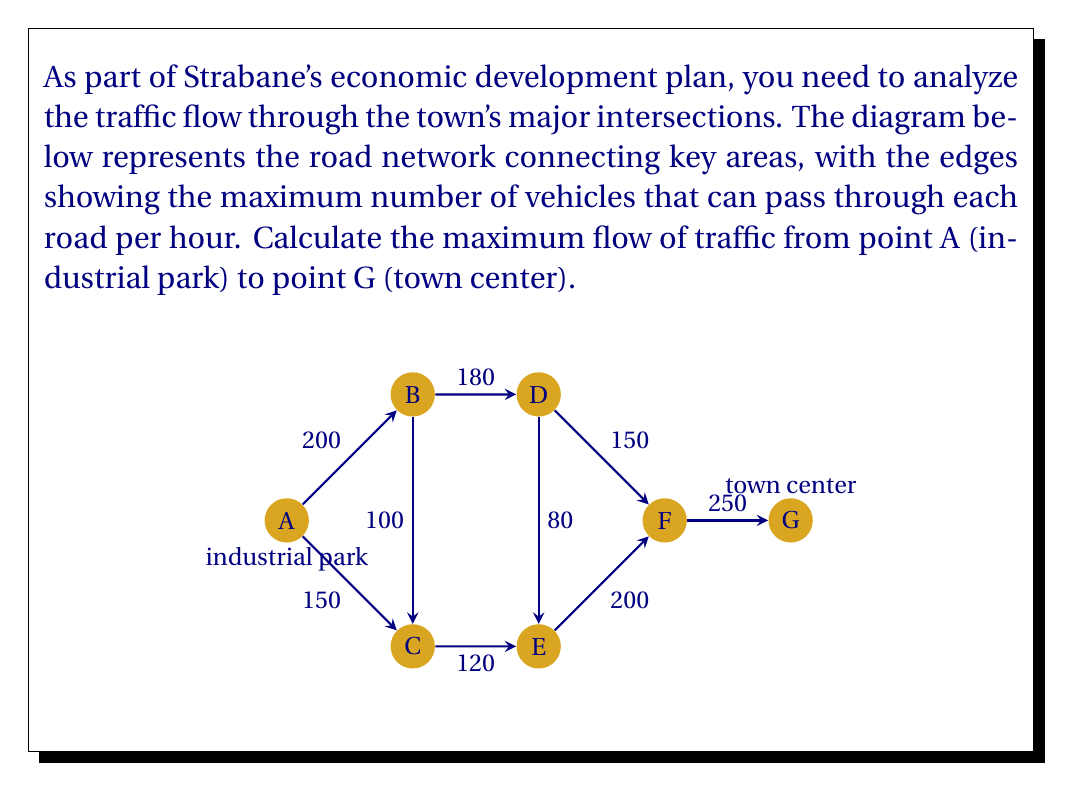Could you help me with this problem? To solve this maximum flow problem, we'll use the Ford-Fulkerson algorithm:

1) Initialize flow on all edges to 0.

2) Find an augmenting path from A to G:
   Path 1: A -> B -> D -> F -> G (min capacity: 150)
   Update flow: 
   A -> B: 150, B -> D: 150, D -> F: 150, F -> G: 150

3) Find another augmenting path:
   Path 2: A -> C -> E -> F -> G (min capacity: 120)
   Update flow:
   A -> C: 120, C -> E: 120, E -> F: 120, F -> G: 120 (total F -> G: 270)

4) Find another augmenting path:
   Path 3: A -> C -> B -> D -> F -> G (min capacity: 30)
   Update flow:
   A -> C: 150, C -> B: 30, B -> D: 30, D -> F: 30, F -> G: 30 (total F -> G: 300)

5) No more augmenting paths exist.

The maximum flow is the sum of all flows leaving the source A:
$$\text{Max Flow} = 150 + 150 = 300$$

This matches the total flow entering the sink G.
Answer: 300 vehicles per hour 